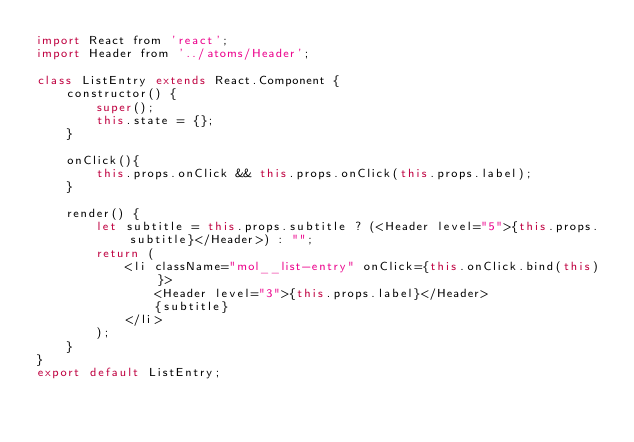<code> <loc_0><loc_0><loc_500><loc_500><_JavaScript_>import React from 'react';
import Header from '../atoms/Header';

class ListEntry extends React.Component {
    constructor() {
        super();
        this.state = {};
    }

    onClick(){
        this.props.onClick && this.props.onClick(this.props.label);
    }

    render() {
        let subtitle = this.props.subtitle ? (<Header level="5">{this.props.subtitle}</Header>) : "";
        return (
            <li className="mol__list-entry" onClick={this.onClick.bind(this)}>
                <Header level="3">{this.props.label}</Header>
                {subtitle}
            </li>
        );
    }
}
export default ListEntry;</code> 